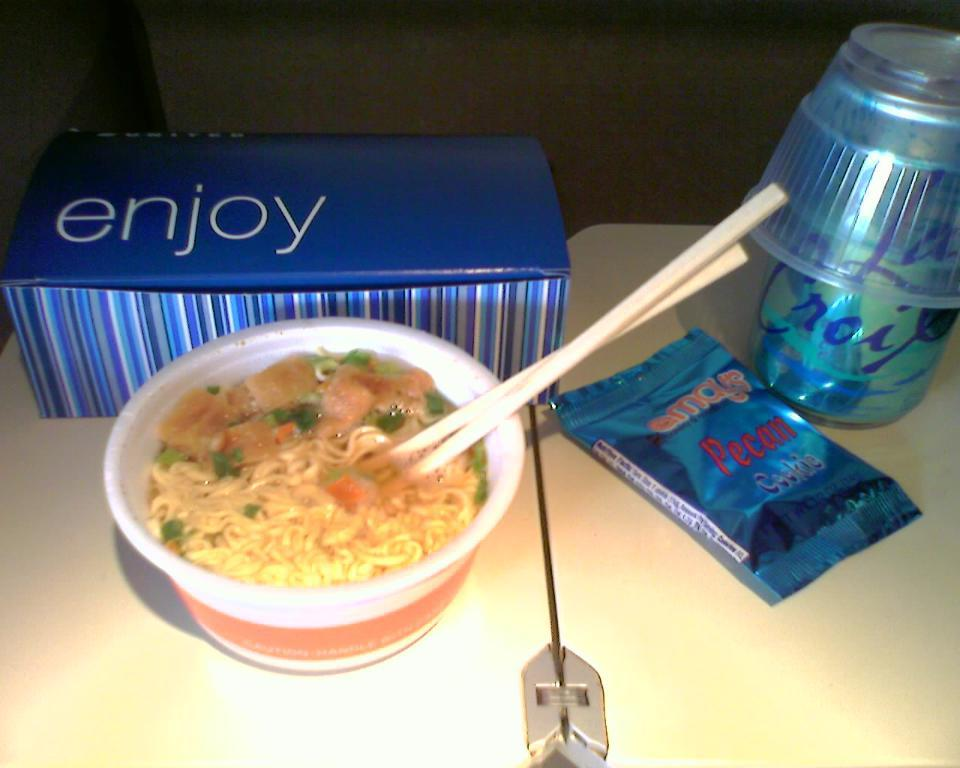<image>
Render a clear and concise summary of the photo. A cardboard box with the word enjoy sits next to a bowl of ramen noodles. 